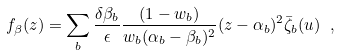<formula> <loc_0><loc_0><loc_500><loc_500>f _ { \beta } ( z ) = \sum _ { b } \frac { \delta \beta _ { b } } { \epsilon } \frac { ( 1 - w _ { b } ) } { w _ { b } ( \alpha _ { b } - \beta _ { b } ) ^ { 2 } } ( z - \alpha _ { b } ) ^ { 2 } \bar { \zeta } _ { b } ( u ) \ ,</formula> 